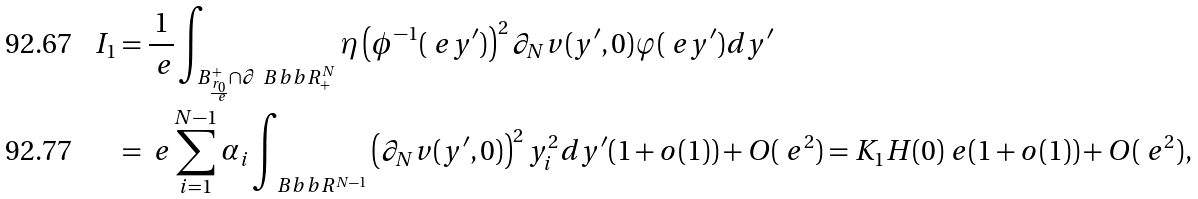Convert formula to latex. <formula><loc_0><loc_0><loc_500><loc_500>I _ { 1 } & = \frac { 1 } { \ e } \int _ { B _ { \frac { r _ { 0 } } { \ e } } ^ { + } \cap \partial \ B b b R ^ { N } _ { + } } \eta \left ( \phi ^ { - 1 } ( \ e y ^ { \prime } ) \right ) ^ { 2 } \partial _ { N } v ( y ^ { \prime } , 0 ) \varphi ( \ e y ^ { \prime } ) d y ^ { \prime } \\ & = \ e \sum _ { i = 1 } ^ { N - 1 } \alpha _ { i } \int _ { \ B b b R ^ { N - 1 } } \left ( \partial _ { N } v ( y ^ { \prime } , 0 ) \right ) ^ { 2 } y _ { i } ^ { 2 } d y ^ { \prime } ( 1 + o ( 1 ) ) + O ( \ e ^ { 2 } ) = K _ { 1 } H ( 0 ) \ e ( 1 + o ( 1 ) ) + O ( \ e ^ { 2 } ) ,</formula> 